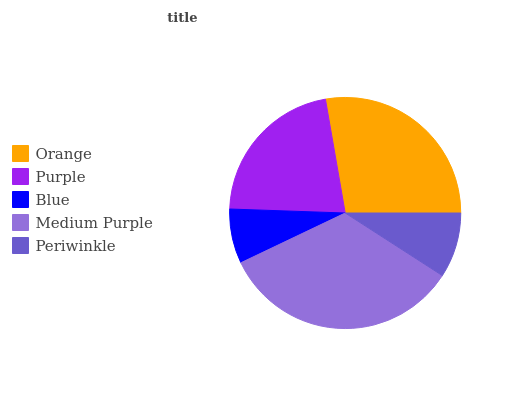Is Blue the minimum?
Answer yes or no. Yes. Is Medium Purple the maximum?
Answer yes or no. Yes. Is Purple the minimum?
Answer yes or no. No. Is Purple the maximum?
Answer yes or no. No. Is Orange greater than Purple?
Answer yes or no. Yes. Is Purple less than Orange?
Answer yes or no. Yes. Is Purple greater than Orange?
Answer yes or no. No. Is Orange less than Purple?
Answer yes or no. No. Is Purple the high median?
Answer yes or no. Yes. Is Purple the low median?
Answer yes or no. Yes. Is Medium Purple the high median?
Answer yes or no. No. Is Periwinkle the low median?
Answer yes or no. No. 